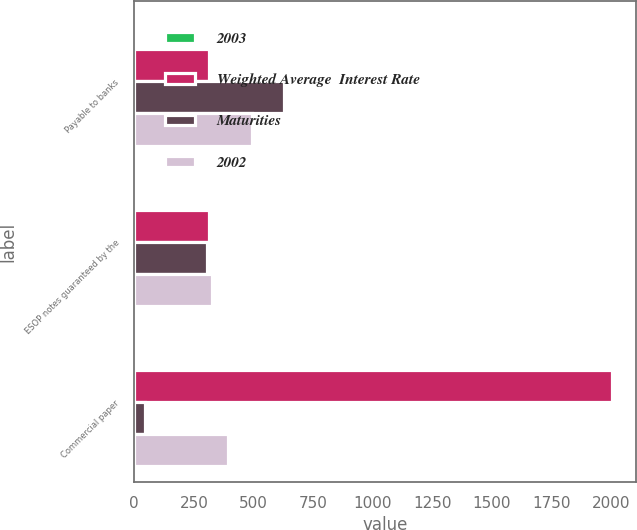<chart> <loc_0><loc_0><loc_500><loc_500><stacked_bar_chart><ecel><fcel>Payable to banks<fcel>ESOP notes guaranteed by the<fcel>Commercial paper<nl><fcel>2003<fcel>3.8<fcel>8.7<fcel>2<nl><fcel>Weighted Average  Interest Rate<fcel>315.6<fcel>315.6<fcel>2004<nl><fcel>Maturities<fcel>626.7<fcel>303.9<fcel>46.1<nl><fcel>2002<fcel>495.7<fcel>327.3<fcel>391.4<nl></chart> 